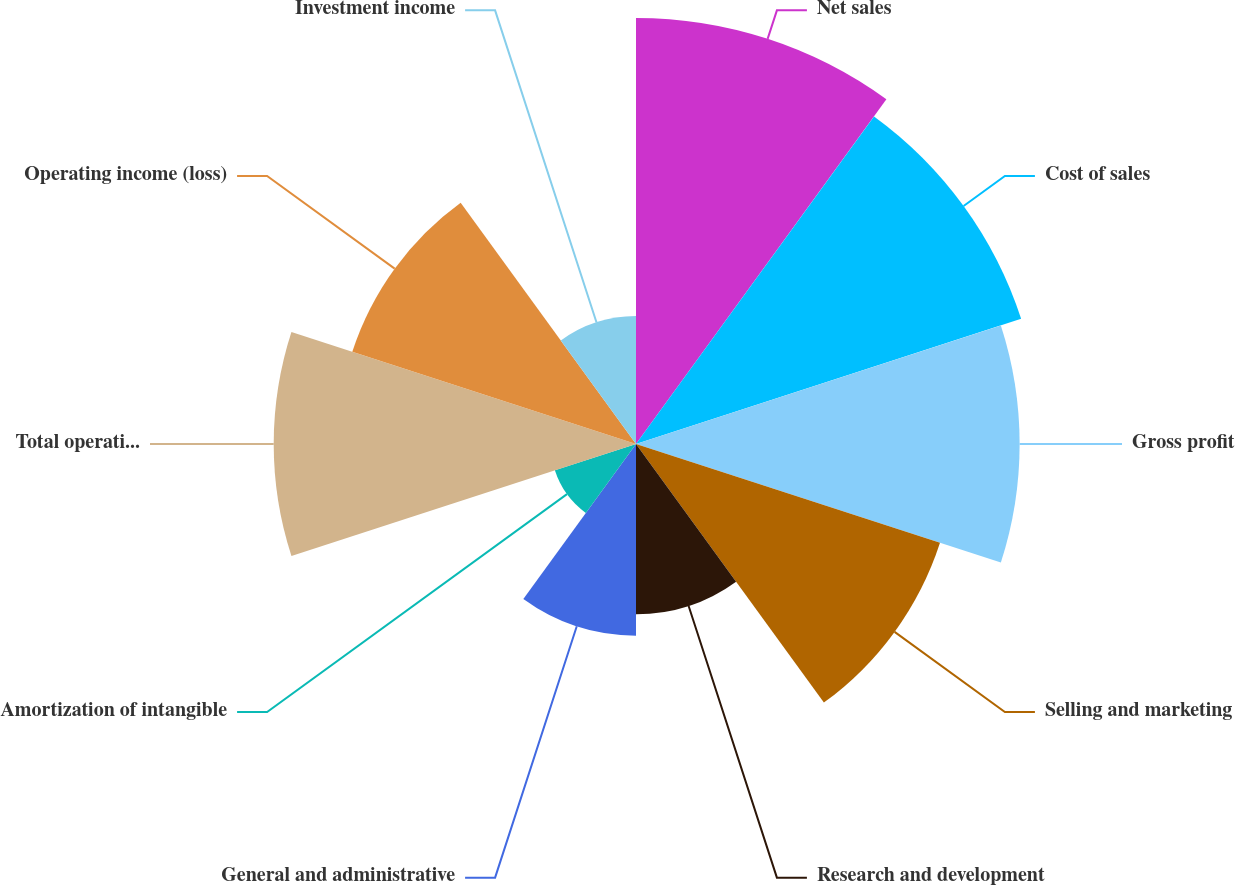Convert chart. <chart><loc_0><loc_0><loc_500><loc_500><pie_chart><fcel>Net sales<fcel>Cost of sales<fcel>Gross profit<fcel>Selling and marketing<fcel>Research and development<fcel>General and administrative<fcel>Amortization of intangible<fcel>Total operating expenses<fcel>Operating income (loss)<fcel>Investment income<nl><fcel>15.38%<fcel>14.62%<fcel>13.85%<fcel>11.54%<fcel>6.15%<fcel>6.92%<fcel>3.08%<fcel>13.08%<fcel>10.77%<fcel>4.62%<nl></chart> 